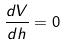Convert formula to latex. <formula><loc_0><loc_0><loc_500><loc_500>\frac { d V } { d h } = 0</formula> 